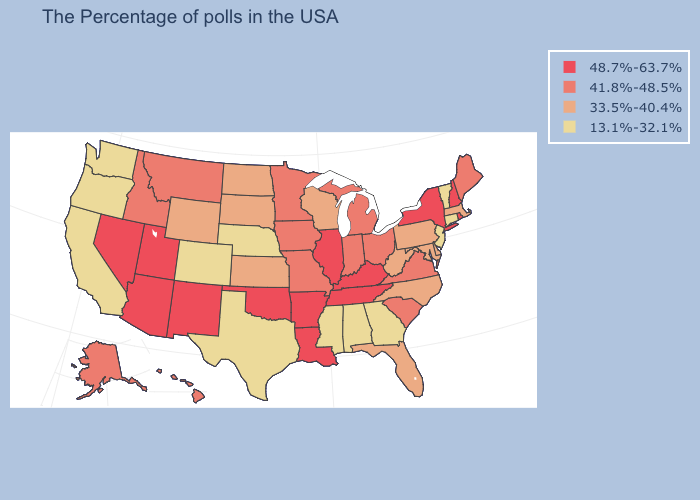Among the states that border Pennsylvania , which have the highest value?
Write a very short answer. New York. Which states have the lowest value in the USA?
Quick response, please. Vermont, Connecticut, New Jersey, Georgia, Alabama, Mississippi, Nebraska, Texas, Colorado, California, Washington, Oregon. What is the highest value in states that border Ohio?
Quick response, please. 48.7%-63.7%. What is the lowest value in the USA?
Short answer required. 13.1%-32.1%. Which states have the highest value in the USA?
Keep it brief. Rhode Island, New Hampshire, New York, Kentucky, Tennessee, Illinois, Louisiana, Arkansas, Oklahoma, New Mexico, Utah, Arizona, Nevada. Among the states that border Wisconsin , does Illinois have the lowest value?
Keep it brief. No. What is the highest value in the West ?
Give a very brief answer. 48.7%-63.7%. Is the legend a continuous bar?
Write a very short answer. No. Which states have the highest value in the USA?
Short answer required. Rhode Island, New Hampshire, New York, Kentucky, Tennessee, Illinois, Louisiana, Arkansas, Oklahoma, New Mexico, Utah, Arizona, Nevada. Among the states that border Pennsylvania , does Maryland have the lowest value?
Answer briefly. No. What is the highest value in the USA?
Answer briefly. 48.7%-63.7%. Which states have the lowest value in the USA?
Answer briefly. Vermont, Connecticut, New Jersey, Georgia, Alabama, Mississippi, Nebraska, Texas, Colorado, California, Washington, Oregon. Name the states that have a value in the range 48.7%-63.7%?
Short answer required. Rhode Island, New Hampshire, New York, Kentucky, Tennessee, Illinois, Louisiana, Arkansas, Oklahoma, New Mexico, Utah, Arizona, Nevada. What is the lowest value in states that border Utah?
Keep it brief. 13.1%-32.1%. Does Hawaii have a lower value than New Hampshire?
Keep it brief. Yes. 